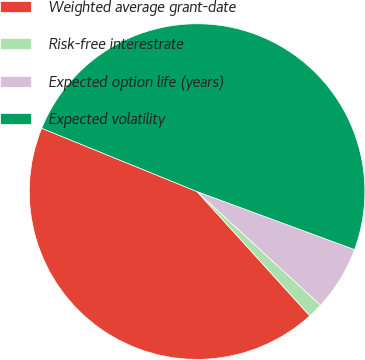Convert chart. <chart><loc_0><loc_0><loc_500><loc_500><pie_chart><fcel>Weighted average grant-date<fcel>Risk-free interestrate<fcel>Expected option life (years)<fcel>Expected volatility<nl><fcel>42.88%<fcel>1.43%<fcel>6.23%<fcel>49.46%<nl></chart> 